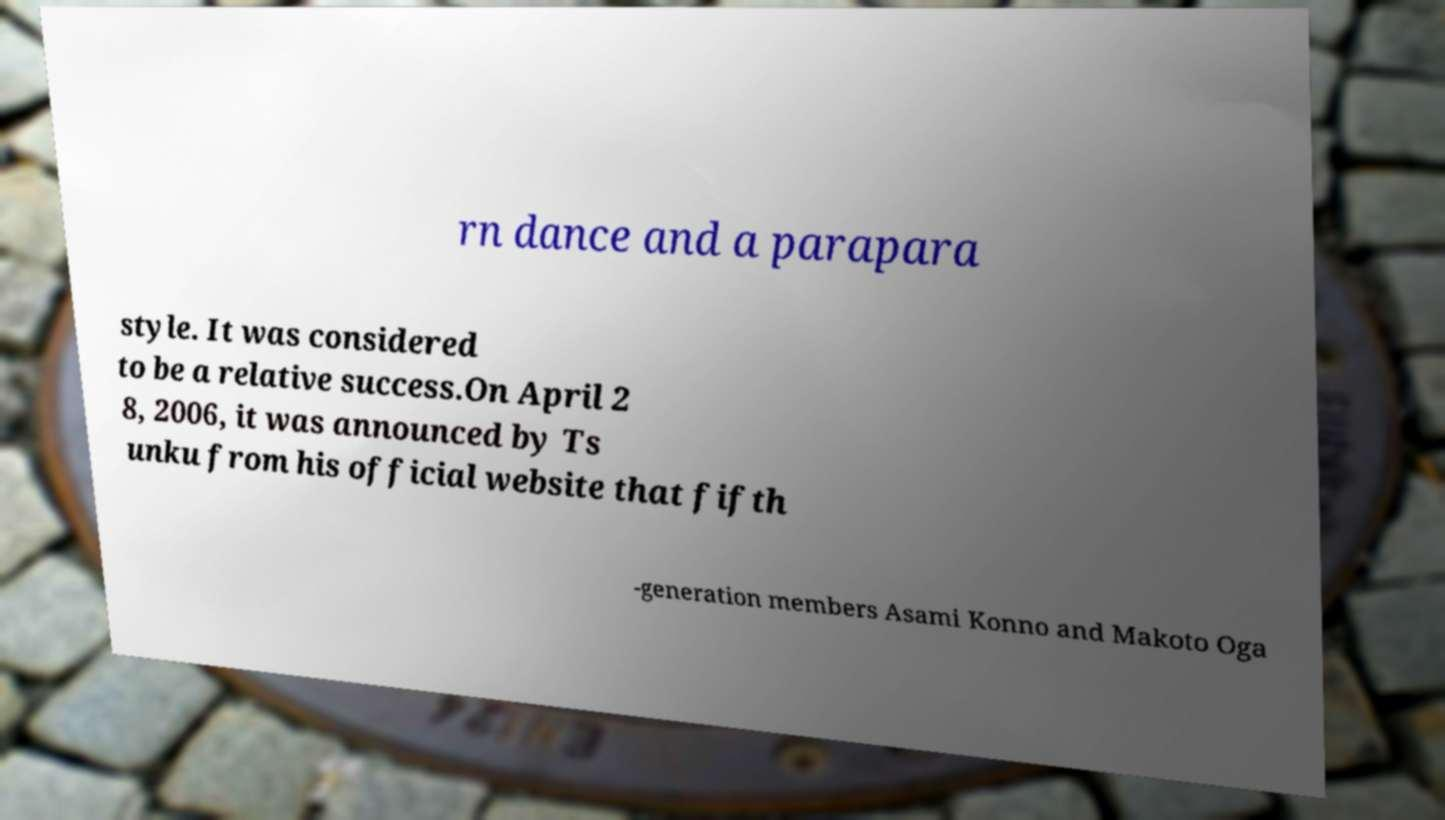I need the written content from this picture converted into text. Can you do that? rn dance and a parapara style. It was considered to be a relative success.On April 2 8, 2006, it was announced by Ts unku from his official website that fifth -generation members Asami Konno and Makoto Oga 